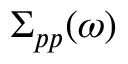<formula> <loc_0><loc_0><loc_500><loc_500>\Sigma _ { p p } ( \omega )</formula> 